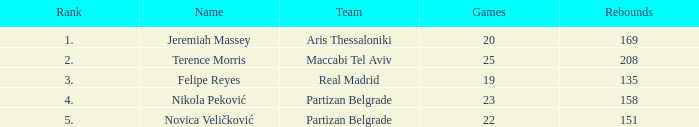In under 22 games, how many rebounds did novica veličković obtain? None. 